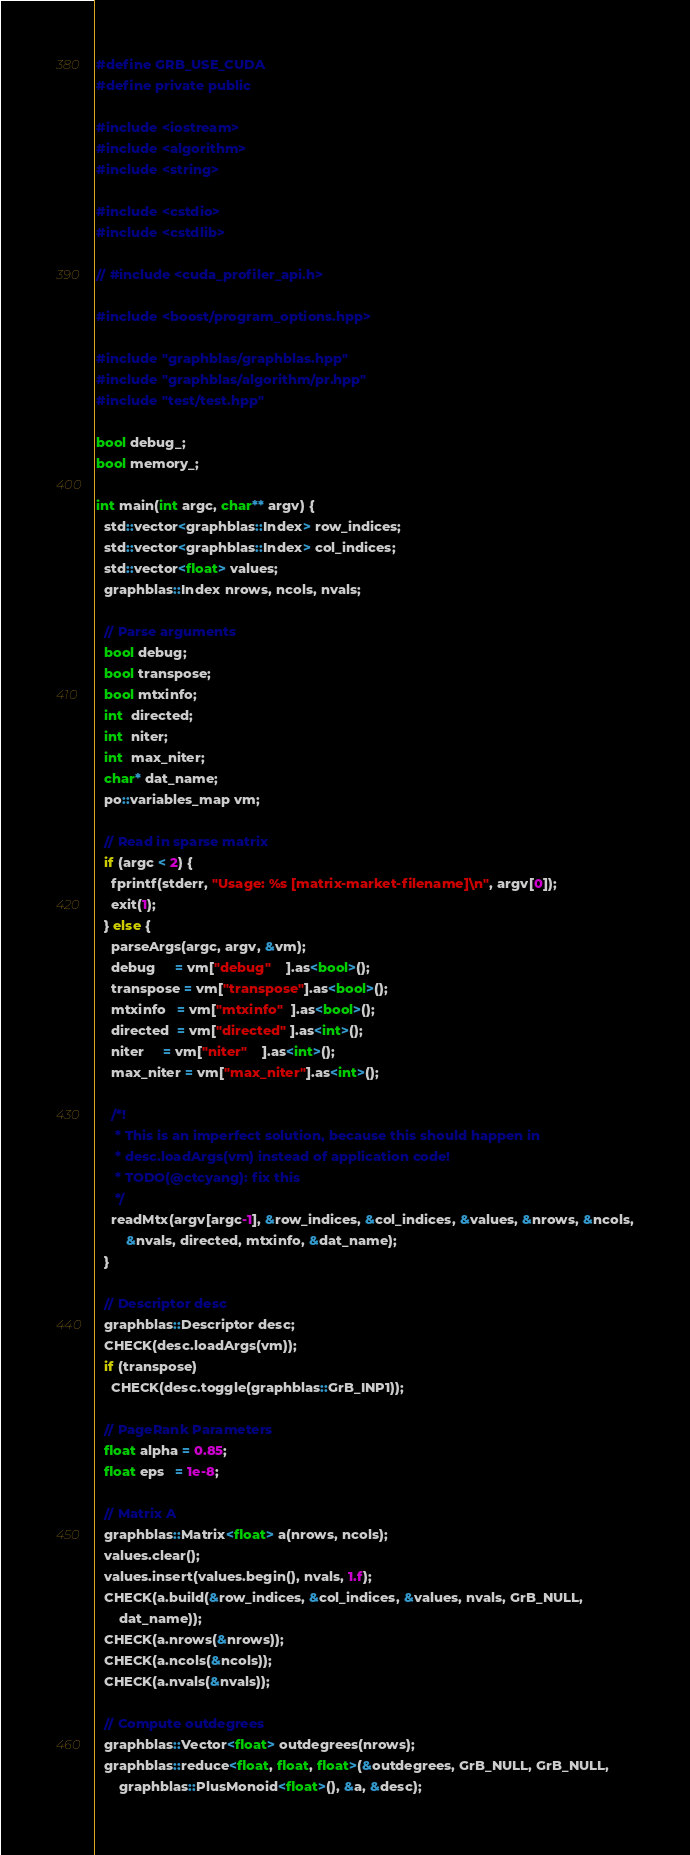Convert code to text. <code><loc_0><loc_0><loc_500><loc_500><_Cuda_>#define GRB_USE_CUDA
#define private public

#include <iostream>
#include <algorithm>
#include <string>

#include <cstdio>
#include <cstdlib>

// #include <cuda_profiler_api.h>

#include <boost/program_options.hpp>

#include "graphblas/graphblas.hpp"
#include "graphblas/algorithm/pr.hpp"
#include "test/test.hpp"

bool debug_;
bool memory_;

int main(int argc, char** argv) {
  std::vector<graphblas::Index> row_indices;
  std::vector<graphblas::Index> col_indices;
  std::vector<float> values;
  graphblas::Index nrows, ncols, nvals;

  // Parse arguments
  bool debug;
  bool transpose;
  bool mtxinfo;
  int  directed;
  int  niter;
  int  max_niter;
  char* dat_name;
  po::variables_map vm;

  // Read in sparse matrix
  if (argc < 2) {
    fprintf(stderr, "Usage: %s [matrix-market-filename]\n", argv[0]);
    exit(1);
  } else {
    parseArgs(argc, argv, &vm);
    debug     = vm["debug"    ].as<bool>();
    transpose = vm["transpose"].as<bool>();
    mtxinfo   = vm["mtxinfo"  ].as<bool>();
    directed  = vm["directed" ].as<int>();
    niter     = vm["niter"    ].as<int>();
    max_niter = vm["max_niter"].as<int>();

    /*!
     * This is an imperfect solution, because this should happen in 
     * desc.loadArgs(vm) instead of application code!
     * TODO(@ctcyang): fix this
     */
    readMtx(argv[argc-1], &row_indices, &col_indices, &values, &nrows, &ncols,
        &nvals, directed, mtxinfo, &dat_name);
  }

  // Descriptor desc
  graphblas::Descriptor desc;
  CHECK(desc.loadArgs(vm));
  if (transpose)
    CHECK(desc.toggle(graphblas::GrB_INP1));

  // PageRank Parameters
  float alpha = 0.85;
  float eps   = 1e-8;

  // Matrix A
  graphblas::Matrix<float> a(nrows, ncols);
  values.clear();
  values.insert(values.begin(), nvals, 1.f);
  CHECK(a.build(&row_indices, &col_indices, &values, nvals, GrB_NULL,
      dat_name));
  CHECK(a.nrows(&nrows));
  CHECK(a.ncols(&ncols));
  CHECK(a.nvals(&nvals));

  // Compute outdegrees
  graphblas::Vector<float> outdegrees(nrows);
  graphblas::reduce<float, float, float>(&outdegrees, GrB_NULL, GrB_NULL,
      graphblas::PlusMonoid<float>(), &a, &desc);
</code> 